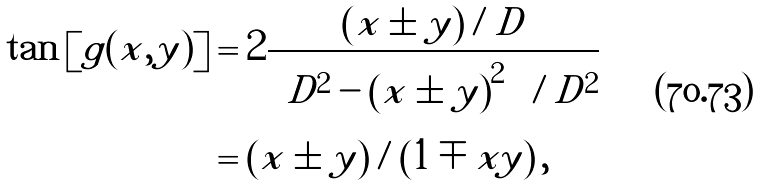Convert formula to latex. <formula><loc_0><loc_0><loc_500><loc_500>\tan \left [ g ( x , y ) \right ] & = 2 \frac { \left ( x \pm y \right ) / D } { \left [ D ^ { 2 } - \left ( x \pm y \right ) ^ { 2 } \right ] / D ^ { 2 } } \\ & = \left ( x \pm y \right ) / \left ( 1 \mp x y \right ) ,</formula> 